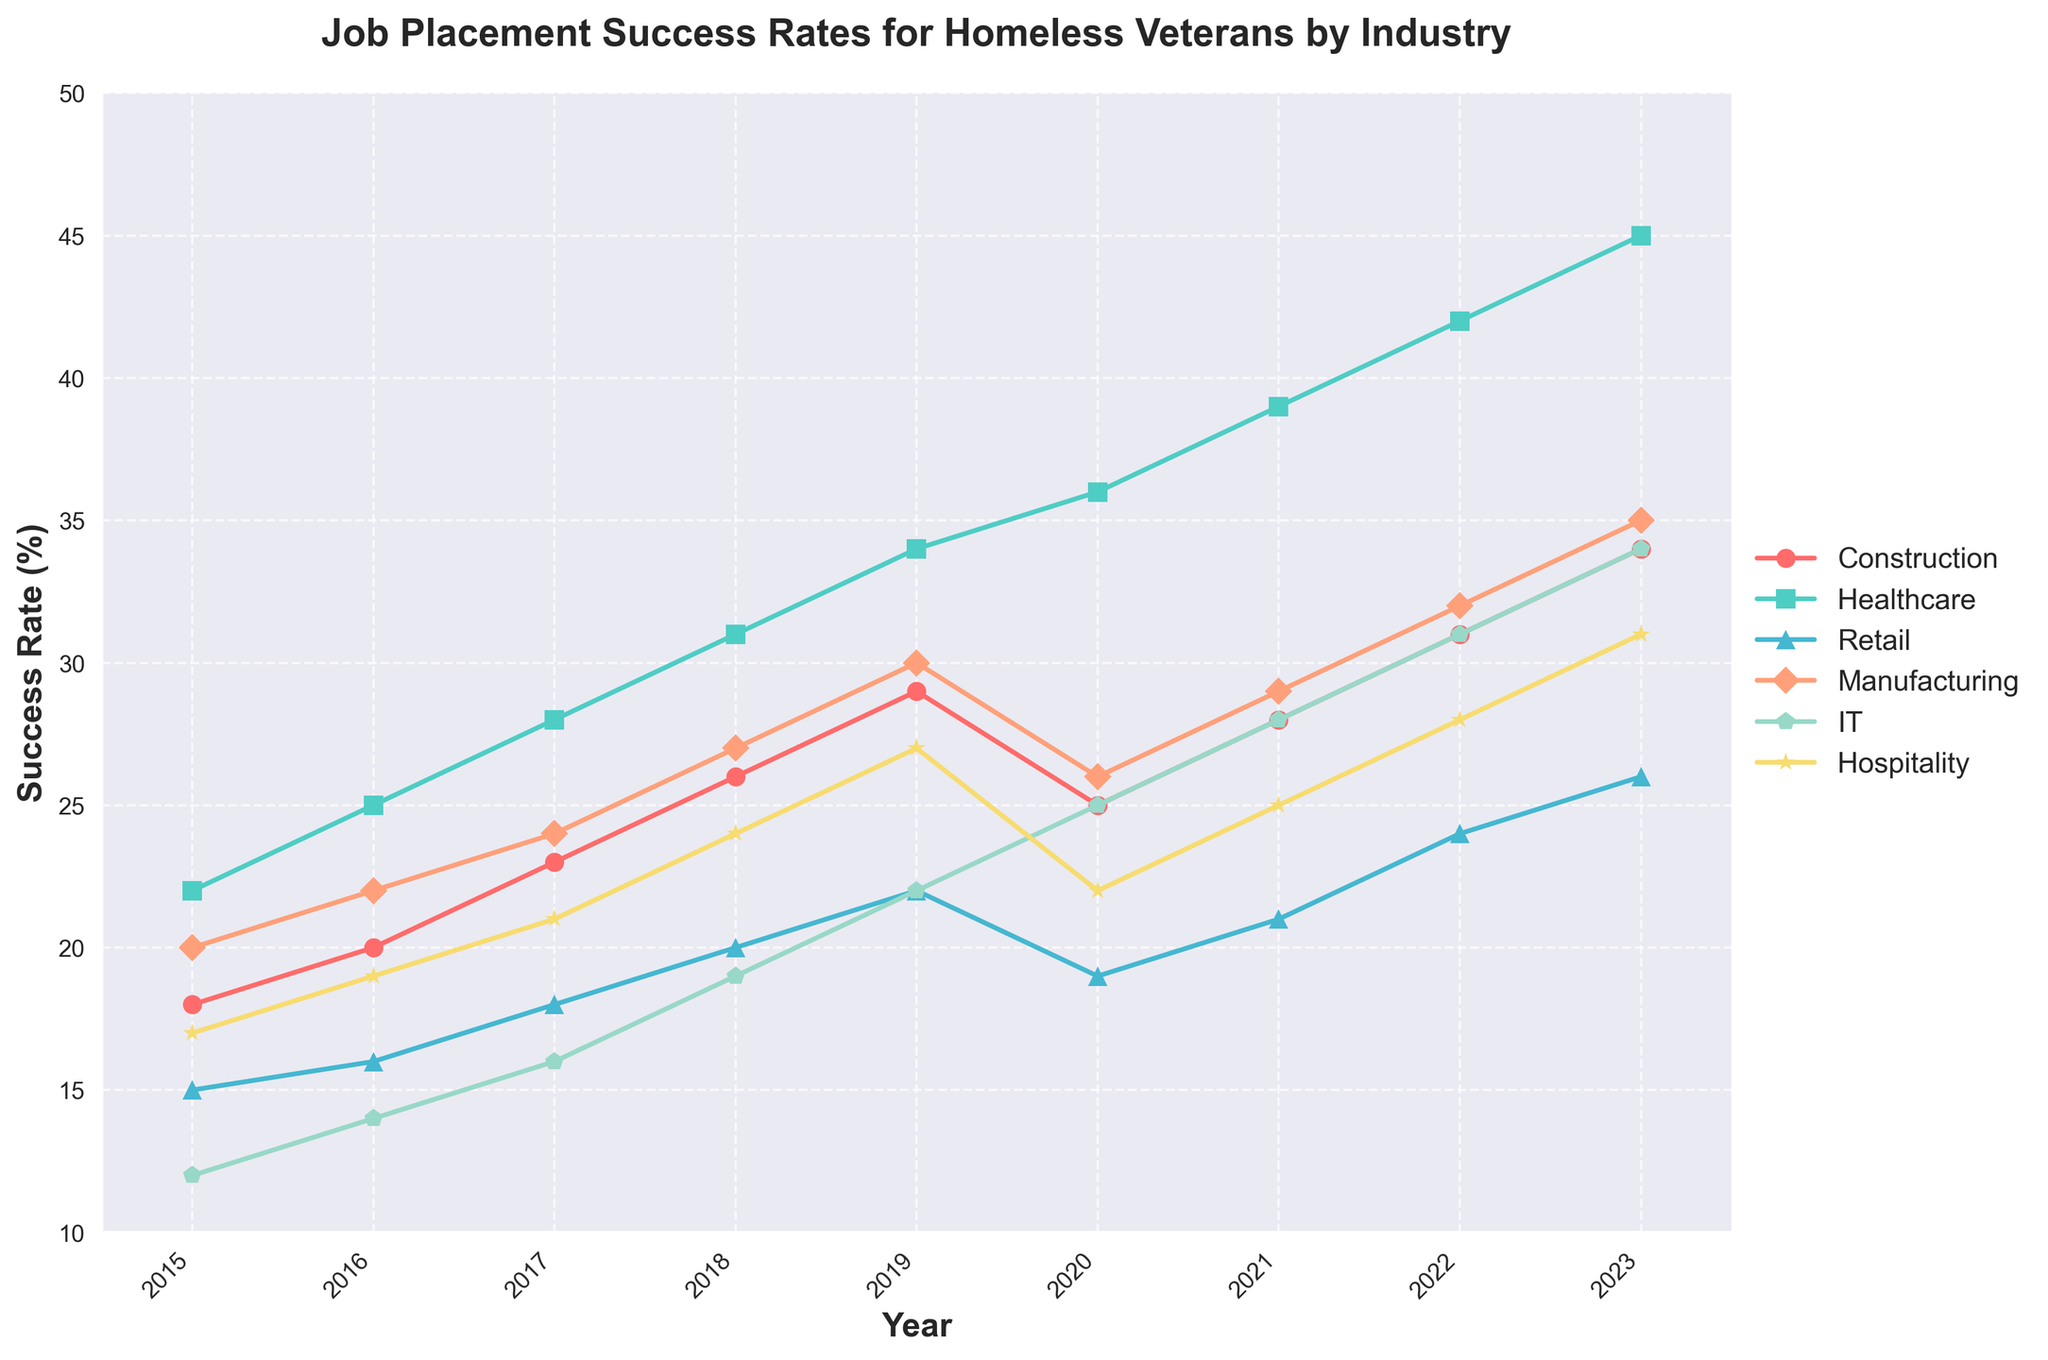What industry had the highest job placement success rate in 2023? In 2023, the line clearly indicates that Healthcare has the highest placement rate at 45%.
Answer: Healthcare Which industry showed a dip in job placement success rates from 2019 to 2020? The lines show that Construction and Retail both had a dip between these years, with Construction dropping from 29% to 25% and Retail from 22% to 19%.
Answer: Construction and Retail In which year did IT surpass Manufacturing in job placement success rates? By following the IT and Manufacturing lines, you can see that IT surpasses Manufacturing in 2020, where IT reaches 25% and Manufacturing dips to 26%.
Answer: 2020 Which sector had the least increase in job placement success rate from 2015 to 2023? Calculating the increase for each sector: Construction (34-18=16), Healthcare (45-22=23), Retail (26-15=11), Manufacturing (35-20=15), IT (34-12=22), Hospitality (31-17=14). Retail shows the least increase (11 percentage points).
Answer: Retail What is the average job placement success rate for Hospitality from 2015 to 2023? The Hospitality success rates from 2015 to 2023 are 17%, 19%, 21%, 24%, 27%, 22%, 25%, 28%, 31%. The sum is 214, and the average is 214/9 ≈ 23.78%.
Answer: 23.78% Which industry had more consistent growth in job placement success rates over the years? Analyzing the lines, Healthcare's growth appears more consistent without significant dips, steadily increasing from 22% in 2015 to 45% in 2023.
Answer: Healthcare By how much did the success rate in Construction grow between 2015 and 2023? The figure shows that Construction had a success rate of 18% in 2015 and grew to 34% in 2023. The increase is 34% - 18% = 16%.
Answer: 16% What is the difference between the success rates of IT and Hospitality in 2023? In 2023, the IT success rate is 34% and Hospitality is 31%. The difference is 34% - 31% = 3%.
Answer: 3% Which year observed the maximum increase in Healthcare job placement success rate? Checking the lines for Healthcare each year: The biggest jump is from 2015 (22%) to 2016 (25%) with a 3 percentage point increase.
Answer: 2015 to 2016 